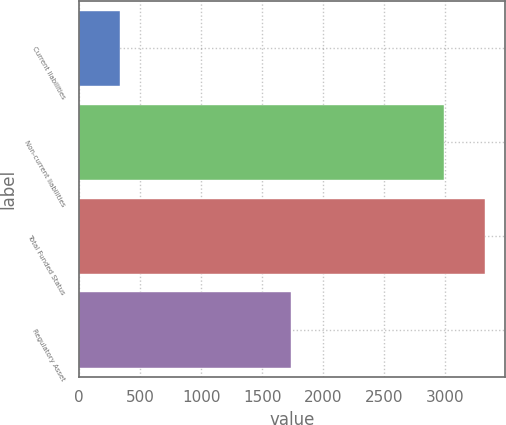<chart> <loc_0><loc_0><loc_500><loc_500><bar_chart><fcel>Current liabilities<fcel>Non-current liabilities<fcel>Total Funded Status<fcel>Regulatory Asset<nl><fcel>332<fcel>2989<fcel>3321<fcel>1736<nl></chart> 